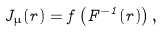<formula> <loc_0><loc_0><loc_500><loc_500>J _ { \mu } ( r ) = f \left ( F ^ { - 1 } ( r ) \right ) ,</formula> 